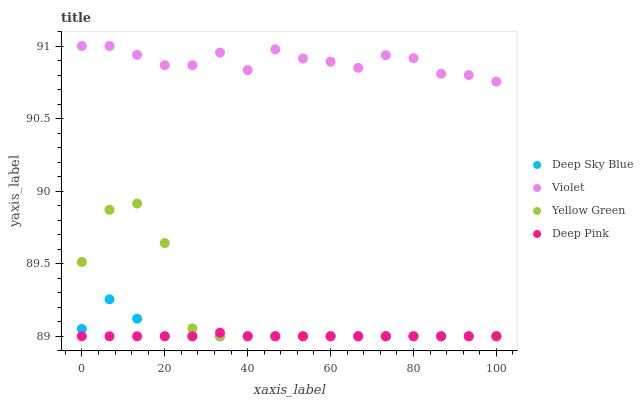Does Deep Pink have the minimum area under the curve?
Answer yes or no. Yes. Does Violet have the maximum area under the curve?
Answer yes or no. Yes. Does Yellow Green have the minimum area under the curve?
Answer yes or no. No. Does Yellow Green have the maximum area under the curve?
Answer yes or no. No. Is Deep Pink the smoothest?
Answer yes or no. Yes. Is Yellow Green the roughest?
Answer yes or no. Yes. Is Deep Sky Blue the smoothest?
Answer yes or no. No. Is Deep Sky Blue the roughest?
Answer yes or no. No. Does Deep Pink have the lowest value?
Answer yes or no. Yes. Does Violet have the lowest value?
Answer yes or no. No. Does Violet have the highest value?
Answer yes or no. Yes. Does Yellow Green have the highest value?
Answer yes or no. No. Is Yellow Green less than Violet?
Answer yes or no. Yes. Is Violet greater than Yellow Green?
Answer yes or no. Yes. Does Deep Pink intersect Deep Sky Blue?
Answer yes or no. Yes. Is Deep Pink less than Deep Sky Blue?
Answer yes or no. No. Is Deep Pink greater than Deep Sky Blue?
Answer yes or no. No. Does Yellow Green intersect Violet?
Answer yes or no. No. 